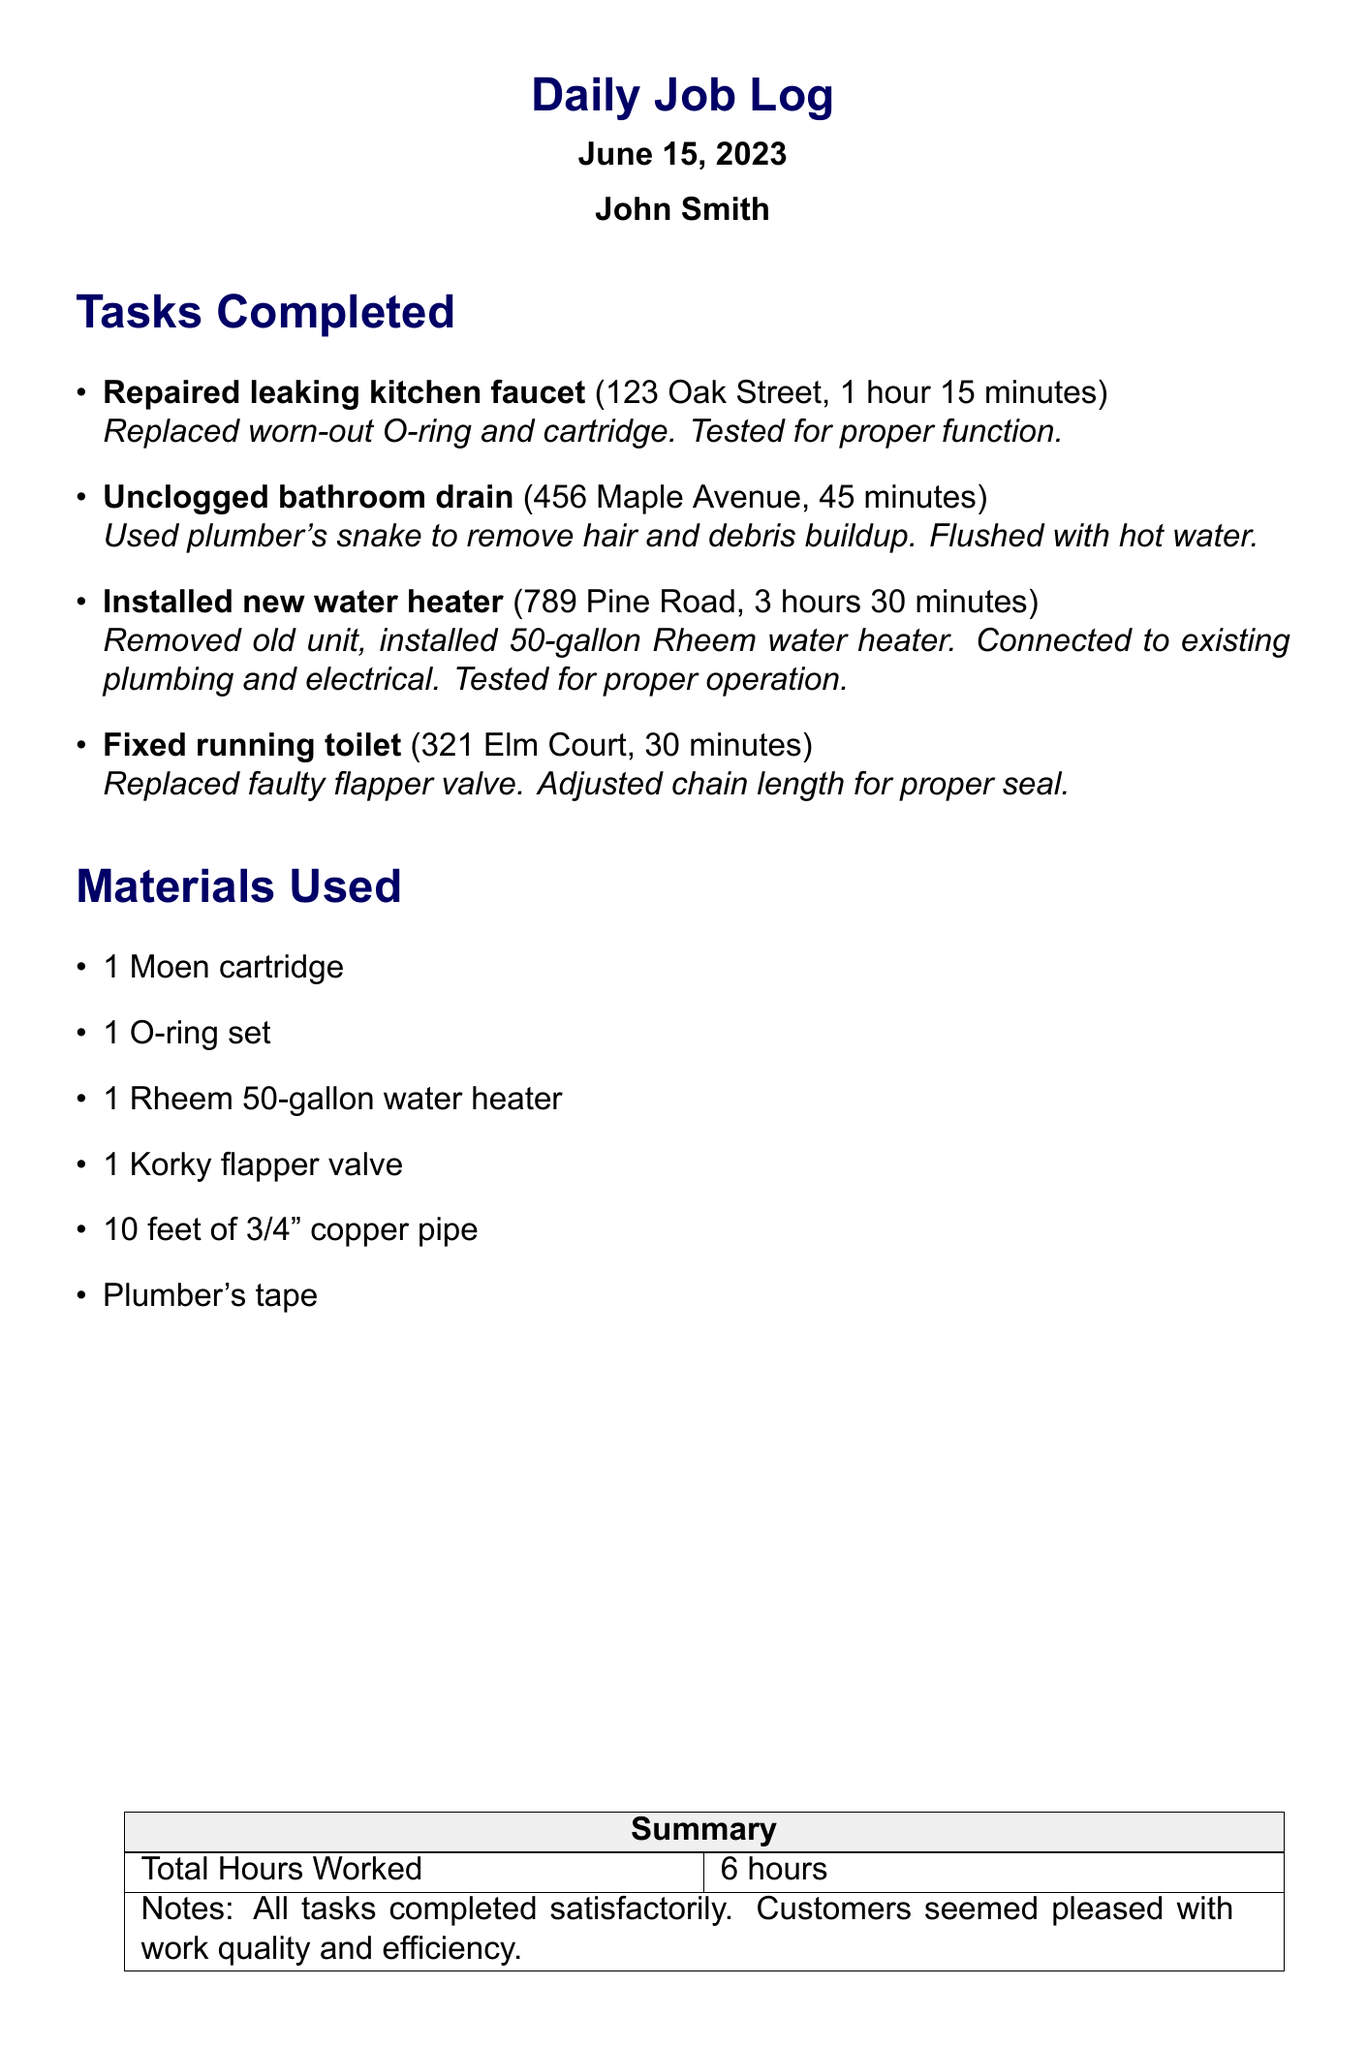What is the date of the log? The date of the log is stated at the beginning of the document under the header.
Answer: June 15, 2023 Who is the plumber? The plumber's name is mentioned alongside the date in the header section.
Answer: John Smith How long did the installation of the new water heater take? The time spent on this task is specified in the list of tasks completed.
Answer: 3 hours 30 minutes What was used to unclog the bathroom drain? The materials used for this task are detailed in the task description.
Answer: Plumber's snake How many total hours were worked? The total hours worked is presented in the summary table at the end of the document.
Answer: 6 hours What type of water heater was installed? The specific model of the water heater is indicated in the task details.
Answer: Rheem 50-gallon water heater What was the issue with the toilet? The problem with the toilet is described in the task details related to fixing it.
Answer: Running toilet What materials were used to repair the leaking kitchen faucet? The document lists the materials used for each task, including this one.
Answer: 1 Moen cartridge, 1 O-ring set What can be inferred about customer satisfaction? The notes section provides feedback about customer reactions to the work completed.
Answer: Customers seemed pleased with work quality and efficiency 